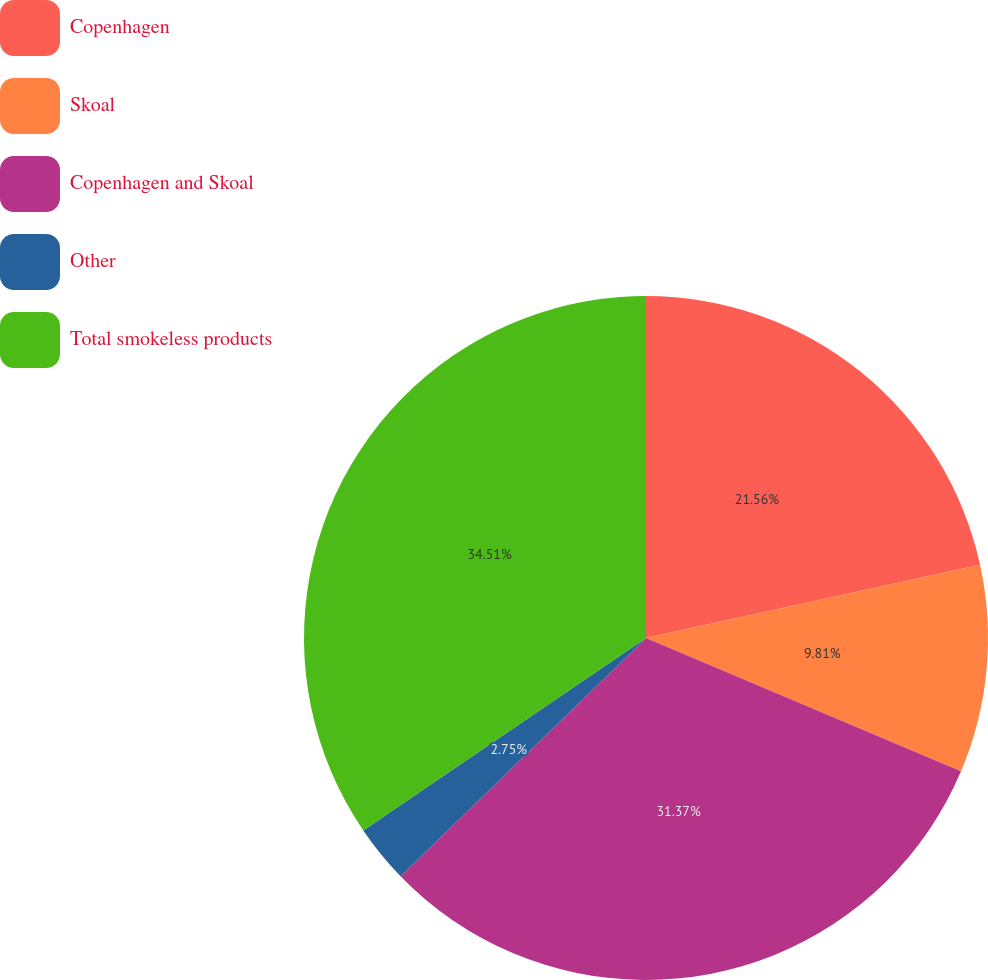Convert chart to OTSL. <chart><loc_0><loc_0><loc_500><loc_500><pie_chart><fcel>Copenhagen<fcel>Skoal<fcel>Copenhagen and Skoal<fcel>Other<fcel>Total smokeless products<nl><fcel>21.56%<fcel>9.81%<fcel>31.37%<fcel>2.75%<fcel>34.51%<nl></chart> 